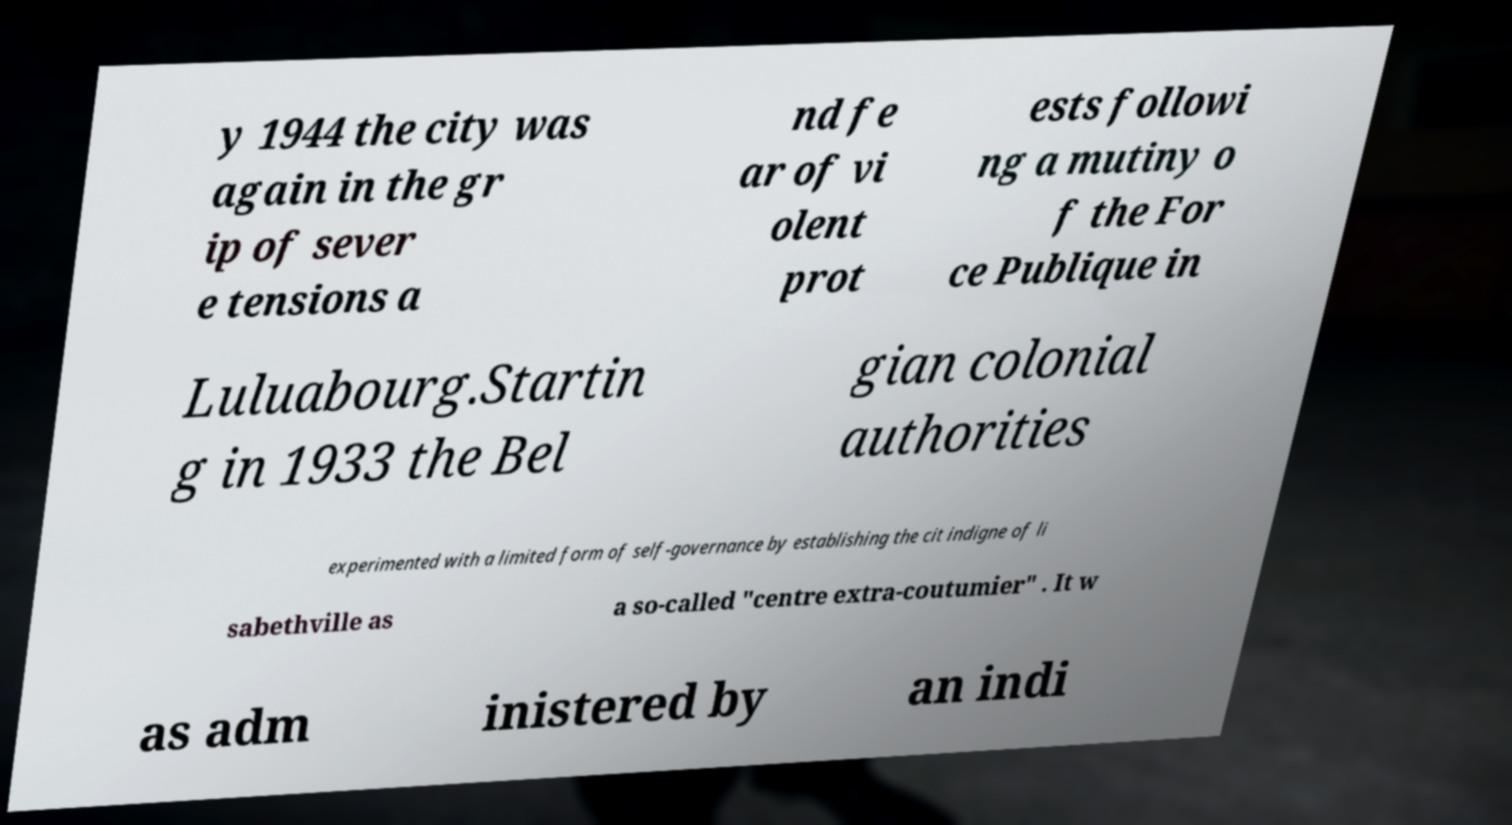There's text embedded in this image that I need extracted. Can you transcribe it verbatim? y 1944 the city was again in the gr ip of sever e tensions a nd fe ar of vi olent prot ests followi ng a mutiny o f the For ce Publique in Luluabourg.Startin g in 1933 the Bel gian colonial authorities experimented with a limited form of self-governance by establishing the cit indigne of li sabethville as a so-called "centre extra-coutumier" . It w as adm inistered by an indi 